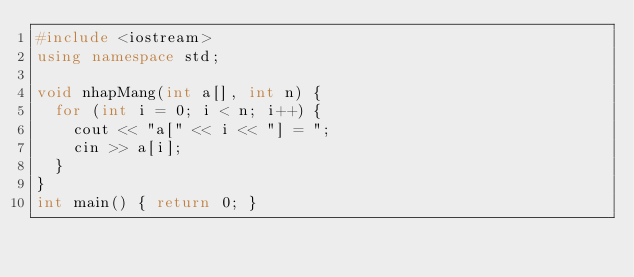<code> <loc_0><loc_0><loc_500><loc_500><_C++_>#include <iostream>
using namespace std;

void nhapMang(int a[], int n) {
  for (int i = 0; i < n; i++) {
    cout << "a[" << i << "] = ";
    cin >> a[i];
  }
}
int main() { return 0; }
</code> 